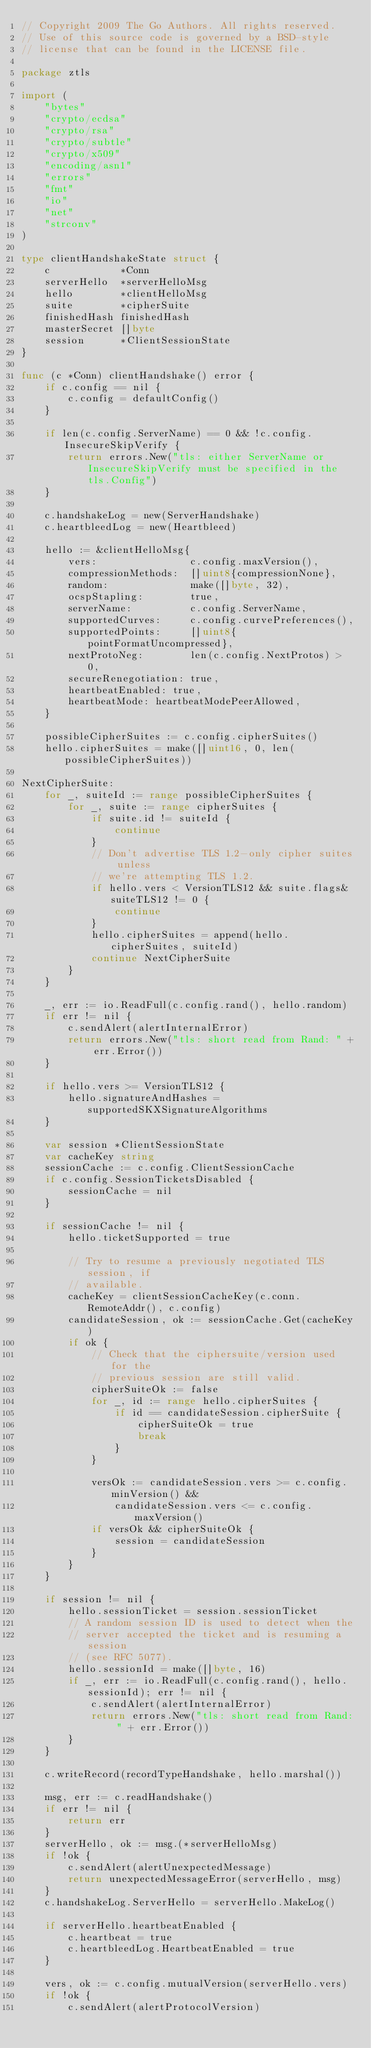Convert code to text. <code><loc_0><loc_0><loc_500><loc_500><_Go_>// Copyright 2009 The Go Authors. All rights reserved.
// Use of this source code is governed by a BSD-style
// license that can be found in the LICENSE file.

package ztls

import (
	"bytes"
	"crypto/ecdsa"
	"crypto/rsa"
	"crypto/subtle"
	"crypto/x509"
	"encoding/asn1"
	"errors"
	"fmt"
	"io"
	"net"
	"strconv"
)

type clientHandshakeState struct {
	c            *Conn
	serverHello  *serverHelloMsg
	hello        *clientHelloMsg
	suite        *cipherSuite
	finishedHash finishedHash
	masterSecret []byte
	session      *ClientSessionState
}

func (c *Conn) clientHandshake() error {
	if c.config == nil {
		c.config = defaultConfig()
	}

	if len(c.config.ServerName) == 0 && !c.config.InsecureSkipVerify {
		return errors.New("tls: either ServerName or InsecureSkipVerify must be specified in the tls.Config")
	}

	c.handshakeLog = new(ServerHandshake)
	c.heartbleedLog = new(Heartbleed)

	hello := &clientHelloMsg{
		vers:                c.config.maxVersion(),
		compressionMethods:  []uint8{compressionNone},
		random:              make([]byte, 32),
		ocspStapling:        true,
		serverName:          c.config.ServerName,
		supportedCurves:     c.config.curvePreferences(),
		supportedPoints:     []uint8{pointFormatUncompressed},
		nextProtoNeg:        len(c.config.NextProtos) > 0,
		secureRenegotiation: true,
		heartbeatEnabled: true,
		heartbeatMode: heartbeatModePeerAllowed,
	}

	possibleCipherSuites := c.config.cipherSuites()
	hello.cipherSuites = make([]uint16, 0, len(possibleCipherSuites))

NextCipherSuite:
	for _, suiteId := range possibleCipherSuites {
		for _, suite := range cipherSuites {
			if suite.id != suiteId {
				continue
			}
			// Don't advertise TLS 1.2-only cipher suites unless
			// we're attempting TLS 1.2.
			if hello.vers < VersionTLS12 && suite.flags&suiteTLS12 != 0 {
				continue
			}
			hello.cipherSuites = append(hello.cipherSuites, suiteId)
			continue NextCipherSuite
		}
	}

	_, err := io.ReadFull(c.config.rand(), hello.random)
	if err != nil {
		c.sendAlert(alertInternalError)
		return errors.New("tls: short read from Rand: " + err.Error())
	}

	if hello.vers >= VersionTLS12 {
		hello.signatureAndHashes = supportedSKXSignatureAlgorithms
	}

	var session *ClientSessionState
	var cacheKey string
	sessionCache := c.config.ClientSessionCache
	if c.config.SessionTicketsDisabled {
		sessionCache = nil
	}

	if sessionCache != nil {
		hello.ticketSupported = true

		// Try to resume a previously negotiated TLS session, if
		// available.
		cacheKey = clientSessionCacheKey(c.conn.RemoteAddr(), c.config)
		candidateSession, ok := sessionCache.Get(cacheKey)
		if ok {
			// Check that the ciphersuite/version used for the
			// previous session are still valid.
			cipherSuiteOk := false
			for _, id := range hello.cipherSuites {
				if id == candidateSession.cipherSuite {
					cipherSuiteOk = true
					break
				}
			}

			versOk := candidateSession.vers >= c.config.minVersion() &&
				candidateSession.vers <= c.config.maxVersion()
			if versOk && cipherSuiteOk {
				session = candidateSession
			}
		}
	}

	if session != nil {
		hello.sessionTicket = session.sessionTicket
		// A random session ID is used to detect when the
		// server accepted the ticket and is resuming a session
		// (see RFC 5077).
		hello.sessionId = make([]byte, 16)
		if _, err := io.ReadFull(c.config.rand(), hello.sessionId); err != nil {
			c.sendAlert(alertInternalError)
			return errors.New("tls: short read from Rand: " + err.Error())
		}
	}

	c.writeRecord(recordTypeHandshake, hello.marshal())

	msg, err := c.readHandshake()
	if err != nil {
		return err
	}
	serverHello, ok := msg.(*serverHelloMsg)
	if !ok {
		c.sendAlert(alertUnexpectedMessage)
		return unexpectedMessageError(serverHello, msg)
	}
	c.handshakeLog.ServerHello = serverHello.MakeLog()

	if serverHello.heartbeatEnabled {
		c.heartbeat = true
		c.heartbleedLog.HeartbeatEnabled = true
	}

	vers, ok := c.config.mutualVersion(serverHello.vers)
	if !ok {
		c.sendAlert(alertProtocolVersion)</code> 